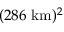Convert formula to latex. <formula><loc_0><loc_0><loc_500><loc_500>( 2 8 6 k m ) ^ { 2 }</formula> 